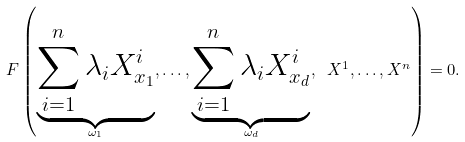Convert formula to latex. <formula><loc_0><loc_0><loc_500><loc_500>F \left ( \underbrace { \sum _ { i = 1 } ^ { n } \lambda _ { i } X ^ { i } _ { x _ { 1 } } } _ { \omega _ { 1 } } , \dots , \underbrace { \sum _ { i = 1 } ^ { n } \lambda _ { i } X ^ { i } _ { x _ { d } } } _ { \omega _ { d } } , \ X ^ { 1 } , \dots , X ^ { n } \right ) = 0 .</formula> 